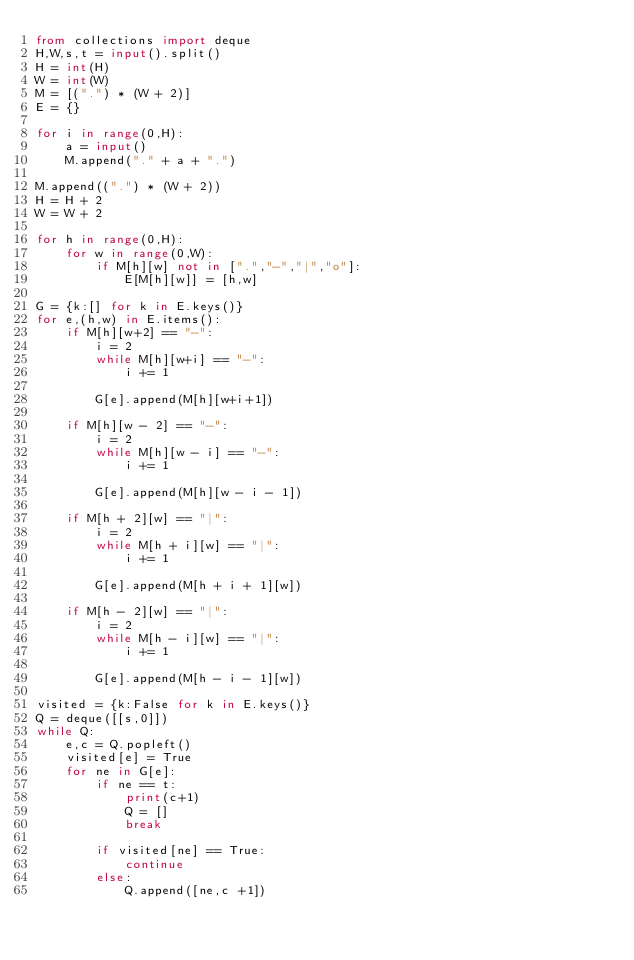Convert code to text. <code><loc_0><loc_0><loc_500><loc_500><_Python_>from collections import deque
H,W,s,t = input().split()
H = int(H)
W = int(W)
M = [(".") * (W + 2)]
E = {}

for i in range(0,H):
    a = input()
    M.append("." + a + ".")

M.append((".") * (W + 2))
H = H + 2
W = W + 2

for h in range(0,H):
    for w in range(0,W):
        if M[h][w] not in [".","-","|","o"]:
            E[M[h][w]] = [h,w]

G = {k:[] for k in E.keys()}
for e,(h,w) in E.items():
    if M[h][w+2] == "-":
        i = 2
        while M[h][w+i] == "-":
            i += 1

        G[e].append(M[h][w+i+1])

    if M[h][w - 2] == "-":
        i = 2
        while M[h][w - i] == "-":
            i += 1

        G[e].append(M[h][w - i - 1])

    if M[h + 2][w] == "|":
        i = 2
        while M[h + i][w] == "|":
            i += 1

        G[e].append(M[h + i + 1][w])

    if M[h - 2][w] == "|":
        i = 2
        while M[h - i][w] == "|":
            i += 1

        G[e].append(M[h - i - 1][w])

visited = {k:False for k in E.keys()}
Q = deque([[s,0]])
while Q:
    e,c = Q.popleft()
    visited[e] = True
    for ne in G[e]:
        if ne == t:
            print(c+1)
            Q = []
            break

        if visited[ne] == True:
            continue
        else:
            Q.append([ne,c +1])


</code> 